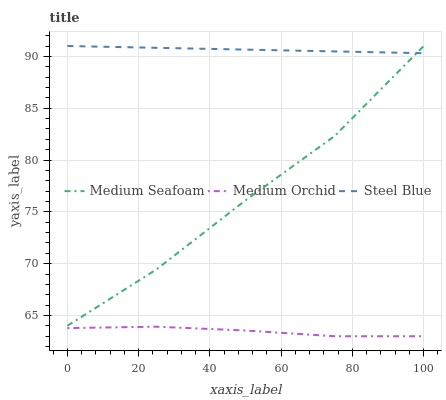Does Medium Orchid have the minimum area under the curve?
Answer yes or no. Yes. Does Steel Blue have the maximum area under the curve?
Answer yes or no. Yes. Does Medium Seafoam have the minimum area under the curve?
Answer yes or no. No. Does Medium Seafoam have the maximum area under the curve?
Answer yes or no. No. Is Steel Blue the smoothest?
Answer yes or no. Yes. Is Medium Seafoam the roughest?
Answer yes or no. Yes. Is Medium Seafoam the smoothest?
Answer yes or no. No. Is Steel Blue the roughest?
Answer yes or no. No. Does Medium Orchid have the lowest value?
Answer yes or no. Yes. Does Medium Seafoam have the lowest value?
Answer yes or no. No. Does Steel Blue have the highest value?
Answer yes or no. Yes. Is Medium Orchid less than Steel Blue?
Answer yes or no. Yes. Is Medium Seafoam greater than Medium Orchid?
Answer yes or no. Yes. Does Medium Seafoam intersect Steel Blue?
Answer yes or no. Yes. Is Medium Seafoam less than Steel Blue?
Answer yes or no. No. Is Medium Seafoam greater than Steel Blue?
Answer yes or no. No. Does Medium Orchid intersect Steel Blue?
Answer yes or no. No. 